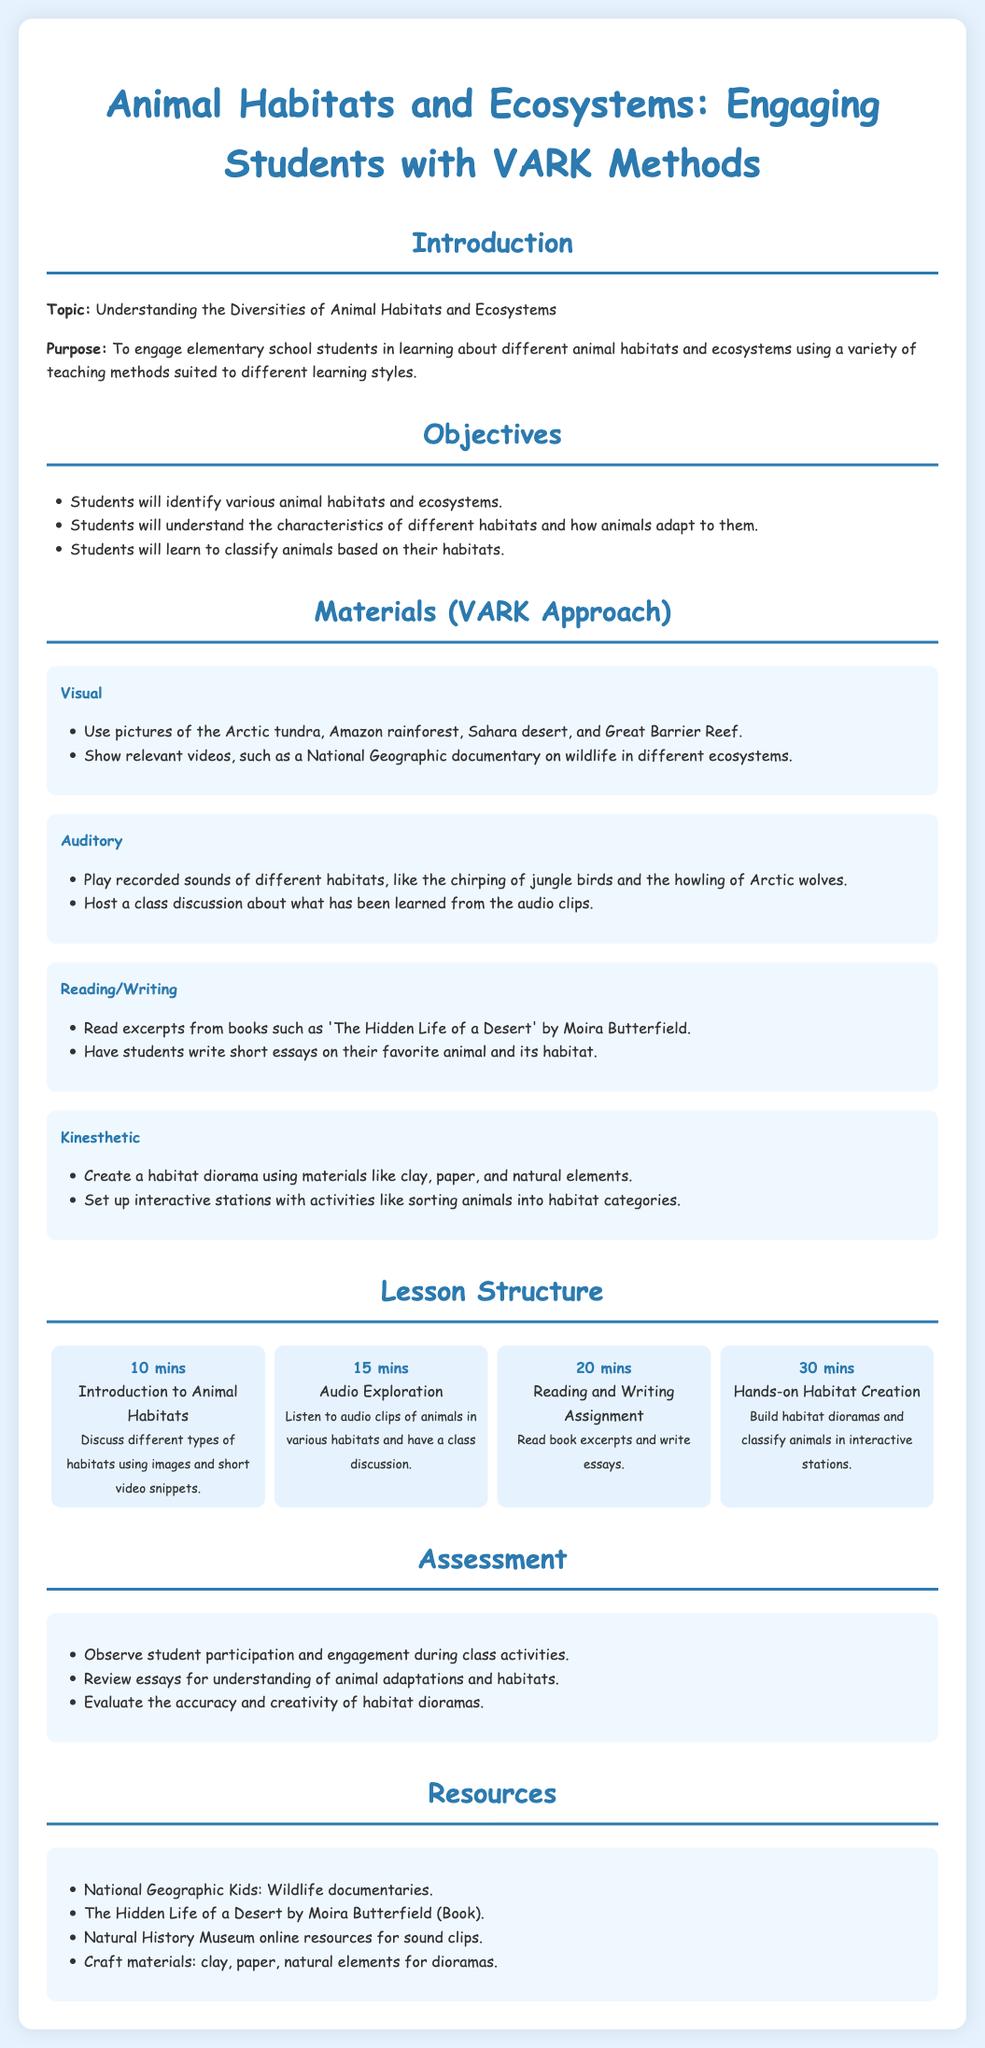What is the main topic of the lesson plan? The document states that the topic is "Understanding the Diversities of Animal Habitats and Ecosystems."
Answer: Understanding the Diversities of Animal Habitats and Ecosystems How many objectives are listed in the lesson plan? The lesson plan contains three specific objectives outlined in the Objectives section.
Answer: 3 What activity takes 30 minutes in the lesson structure? The document specifies that "Hands-on Habitat Creation" is the activity taking 30 minutes.
Answer: Hands-on Habitat Creation Which book is mentioned for the Reading/Writing section? The document lists 'The Hidden Life of a Desert' by Moira Butterfield as a resource for reading and writing.
Answer: The Hidden Life of a Desert What type of materials are used for creating habitat dioramas? The document mentions that students can use clay, paper, and natural elements for diorama creation.
Answer: Clay, paper, and natural elements What audio activity involves class discussions? The lesson plan specifies that "Audio Exploration" involves listening to audio clips and having a class discussion.
Answer: Audio Exploration What is one criteria for assessing students? The assessment section includes observing student participation and engagement during activities as a criterion.
Answer: Observe student participation and engagement Which educational source is listed for wildlife documentaries? The document references National Geographic Kids as a resource for wildlife documentaries.
Answer: National Geographic Kids 